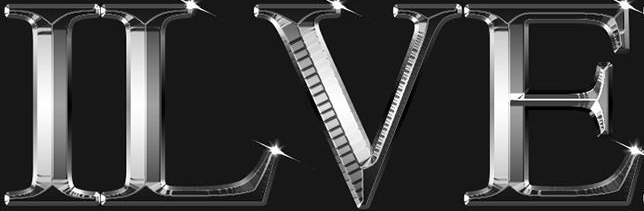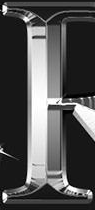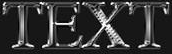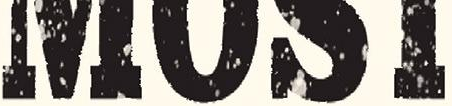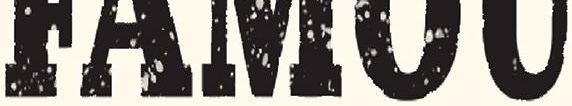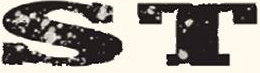Identify the words shown in these images in order, separated by a semicolon. ILVE; #; TEXT; ####; #####; ST 